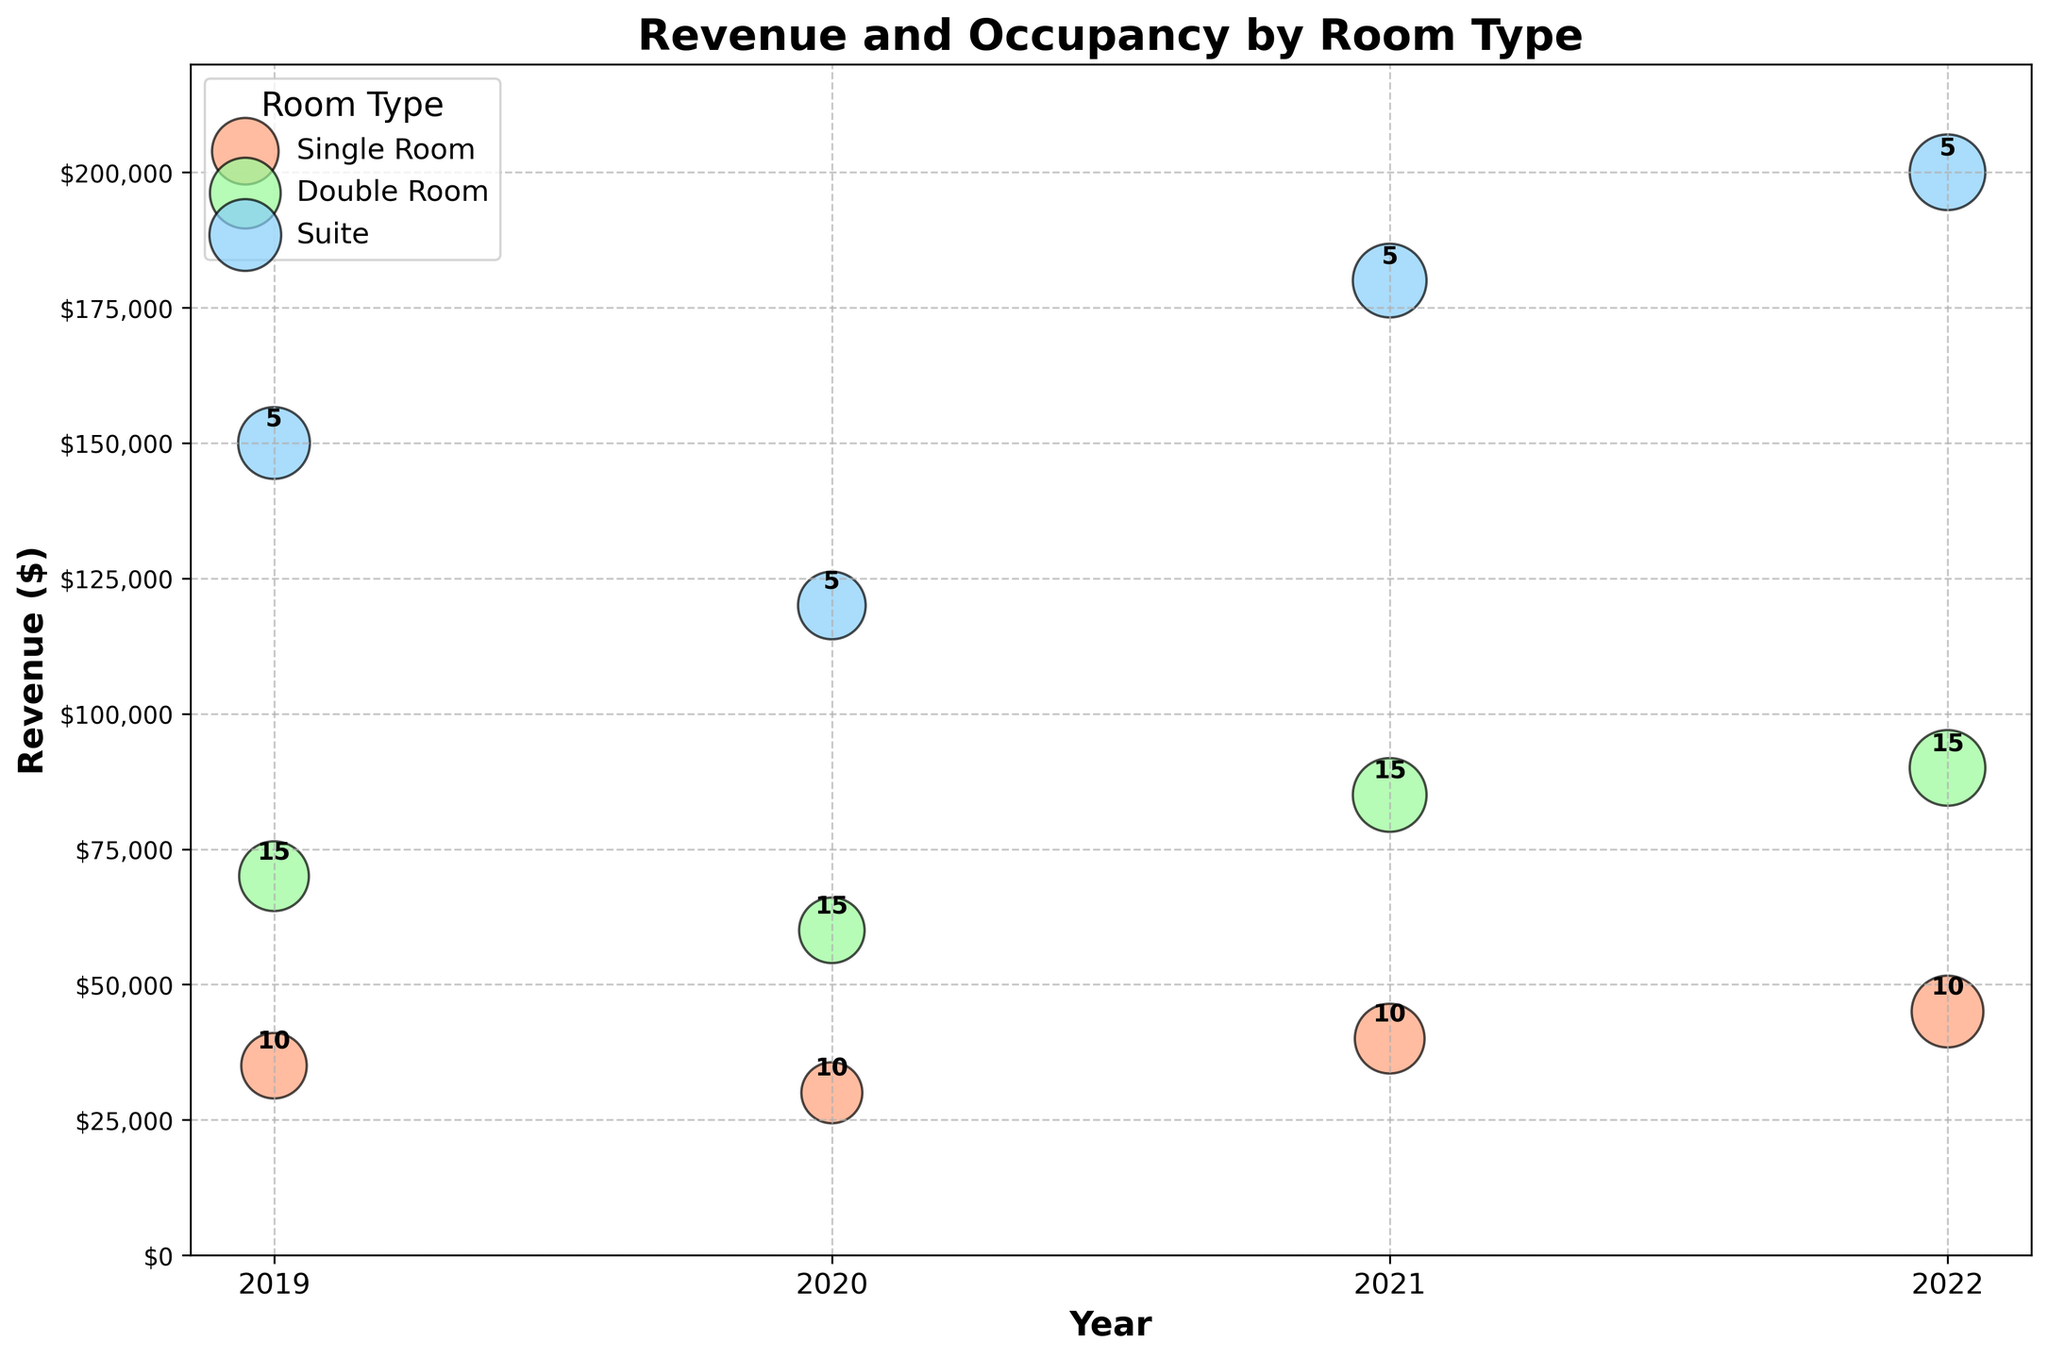What's the title of the chart? The title of the chart is usually displayed prominently at the top of the figure.
Answer: Revenue and Occupancy by Room Type What do the sizes of the bubbles represent? The sizes of the bubbles are indicative of average occupancy, as larger bubbles represent higher occupancy rates.
Answer: Average occupancy Which year had the highest revenue for Suite rooms? Look for the bubble with the highest position on the y-axis in the "Suite" category and note the corresponding year.
Answer: 2022 How does the revenue for Single Rooms in 2019 compare to Double Rooms in the same year? Identify the positions of the bubbles for Single and Double Rooms in 2019 on the y-axis. The bubble for Double Rooms in 2019 is higher, indicating greater revenue.
Answer: Double Rooms had higher revenue In which year did Single Rooms have their lowest revenue? Find the lowest position on the y-axis among the bubbles for Single Rooms.
Answer: 2020 How many Double Rooms were there in 2021? Look for the number annotated beside the Double Room bubble in 2021.
Answer: 15 Did the revenue for Suite rooms increase every year? Observe the vertical positions of the Suite bubbles for each year to see if they consistently rise.
Answer: Yes What color represents the Double Room data points? Identify the color of the bubbles specifically labeled as Double Rooms in the legend.
Answer: Light green By how much did the revenue for Double Rooms change from 2020 to 2021? Subtract the revenue value for Double Rooms in 2020 (60,000) from the value in 2021 (85,000).
Answer: 25,000 Which room type had the highest average occupancy rate in 2022? Compare the sizes of the bubbles for each room type in 2022; the largest bubble indicates the highest average occupancy.
Answer: Double Room and Suite (tied) 